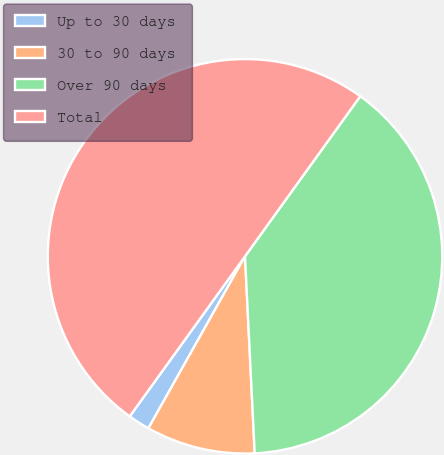<chart> <loc_0><loc_0><loc_500><loc_500><pie_chart><fcel>Up to 30 days<fcel>30 to 90 days<fcel>Over 90 days<fcel>Total<nl><fcel>1.79%<fcel>8.93%<fcel>39.29%<fcel>50.0%<nl></chart> 